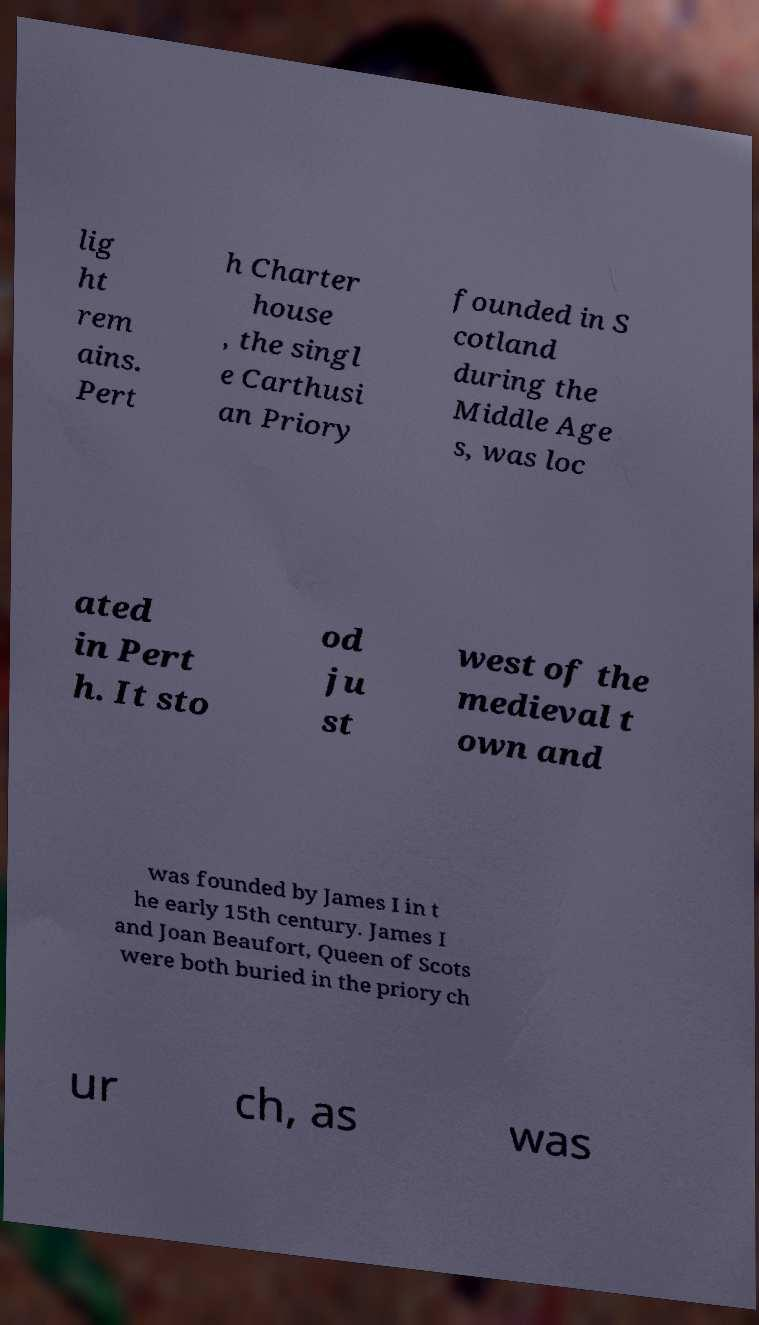Please identify and transcribe the text found in this image. lig ht rem ains. Pert h Charter house , the singl e Carthusi an Priory founded in S cotland during the Middle Age s, was loc ated in Pert h. It sto od ju st west of the medieval t own and was founded by James I in t he early 15th century. James I and Joan Beaufort, Queen of Scots were both buried in the priory ch ur ch, as was 